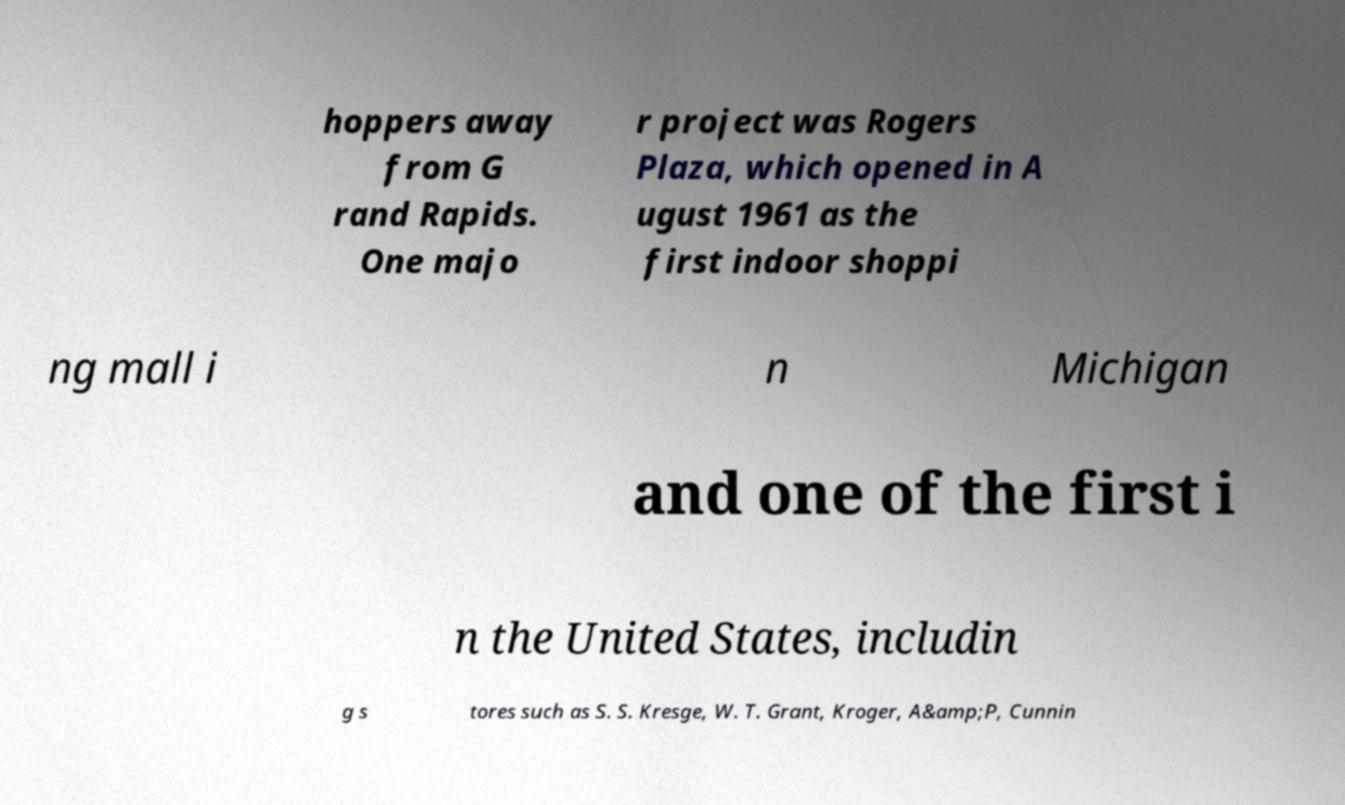There's text embedded in this image that I need extracted. Can you transcribe it verbatim? hoppers away from G rand Rapids. One majo r project was Rogers Plaza, which opened in A ugust 1961 as the first indoor shoppi ng mall i n Michigan and one of the first i n the United States, includin g s tores such as S. S. Kresge, W. T. Grant, Kroger, A&amp;P, Cunnin 